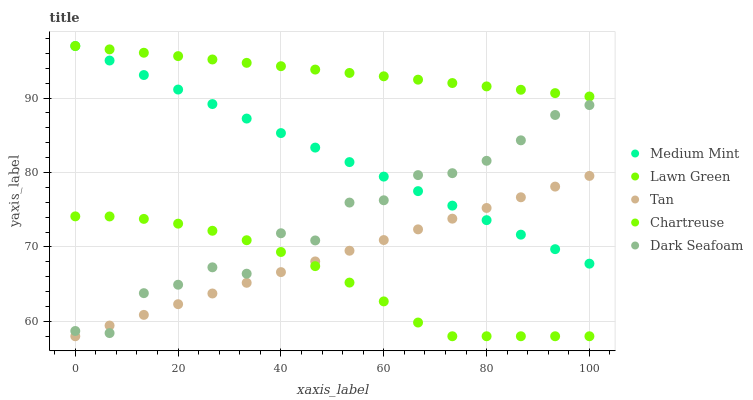Does Chartreuse have the minimum area under the curve?
Answer yes or no. Yes. Does Lawn Green have the maximum area under the curve?
Answer yes or no. Yes. Does Tan have the minimum area under the curve?
Answer yes or no. No. Does Tan have the maximum area under the curve?
Answer yes or no. No. Is Tan the smoothest?
Answer yes or no. Yes. Is Dark Seafoam the roughest?
Answer yes or no. Yes. Is Lawn Green the smoothest?
Answer yes or no. No. Is Lawn Green the roughest?
Answer yes or no. No. Does Tan have the lowest value?
Answer yes or no. Yes. Does Lawn Green have the lowest value?
Answer yes or no. No. Does Lawn Green have the highest value?
Answer yes or no. Yes. Does Tan have the highest value?
Answer yes or no. No. Is Dark Seafoam less than Lawn Green?
Answer yes or no. Yes. Is Lawn Green greater than Chartreuse?
Answer yes or no. Yes. Does Medium Mint intersect Dark Seafoam?
Answer yes or no. Yes. Is Medium Mint less than Dark Seafoam?
Answer yes or no. No. Is Medium Mint greater than Dark Seafoam?
Answer yes or no. No. Does Dark Seafoam intersect Lawn Green?
Answer yes or no. No. 